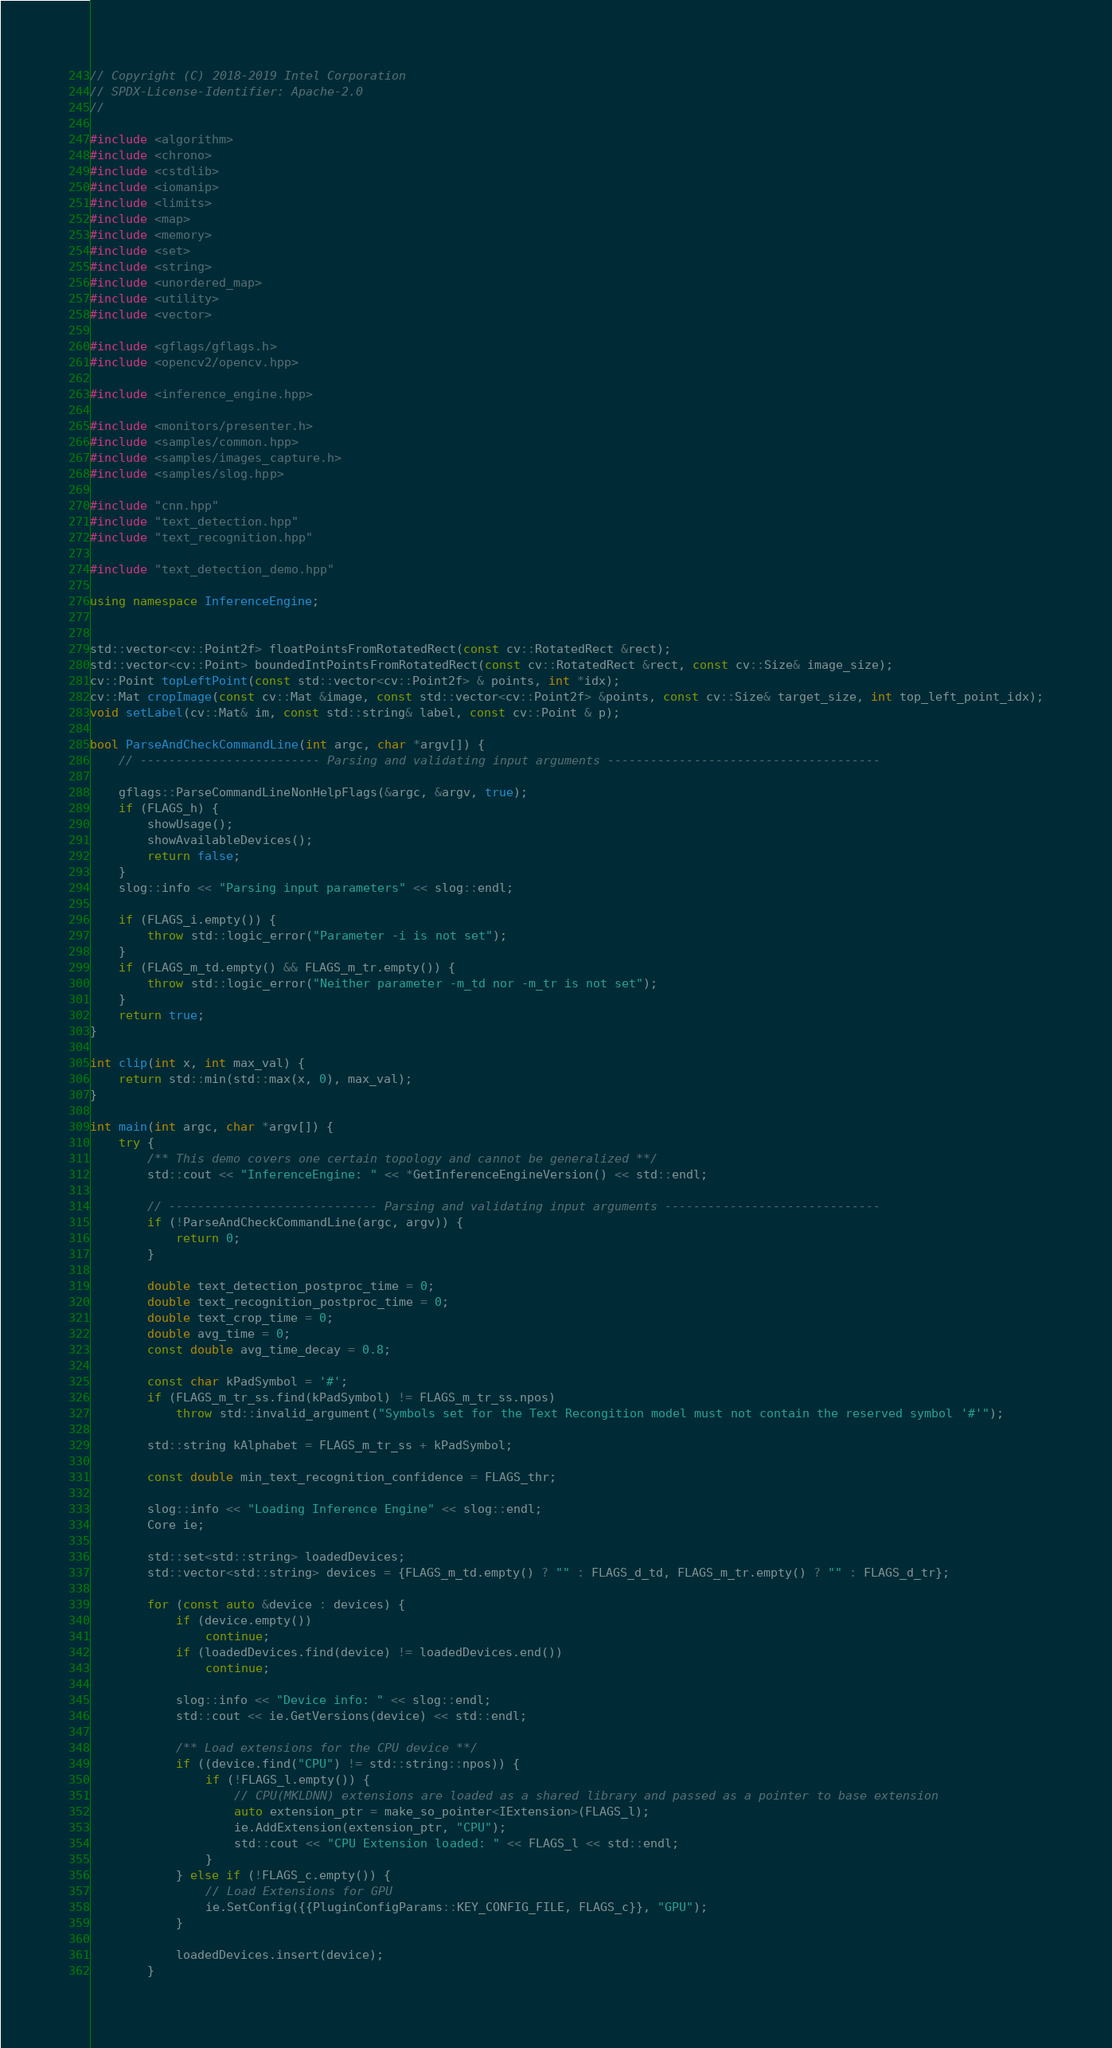Convert code to text. <code><loc_0><loc_0><loc_500><loc_500><_C++_>// Copyright (C) 2018-2019 Intel Corporation
// SPDX-License-Identifier: Apache-2.0
//

#include <algorithm>
#include <chrono>
#include <cstdlib>
#include <iomanip>
#include <limits>
#include <map>
#include <memory>
#include <set>
#include <string>
#include <unordered_map>
#include <utility>
#include <vector>

#include <gflags/gflags.h>
#include <opencv2/opencv.hpp>

#include <inference_engine.hpp>

#include <monitors/presenter.h>
#include <samples/common.hpp>
#include <samples/images_capture.h>
#include <samples/slog.hpp>

#include "cnn.hpp"
#include "text_detection.hpp"
#include "text_recognition.hpp"

#include "text_detection_demo.hpp"

using namespace InferenceEngine;


std::vector<cv::Point2f> floatPointsFromRotatedRect(const cv::RotatedRect &rect);
std::vector<cv::Point> boundedIntPointsFromRotatedRect(const cv::RotatedRect &rect, const cv::Size& image_size);
cv::Point topLeftPoint(const std::vector<cv::Point2f> & points, int *idx);
cv::Mat cropImage(const cv::Mat &image, const std::vector<cv::Point2f> &points, const cv::Size& target_size, int top_left_point_idx);
void setLabel(cv::Mat& im, const std::string& label, const cv::Point & p);

bool ParseAndCheckCommandLine(int argc, char *argv[]) {
    // ------------------------- Parsing and validating input arguments --------------------------------------

    gflags::ParseCommandLineNonHelpFlags(&argc, &argv, true);
    if (FLAGS_h) {
        showUsage();
        showAvailableDevices();
        return false;
    }
    slog::info << "Parsing input parameters" << slog::endl;

    if (FLAGS_i.empty()) {
        throw std::logic_error("Parameter -i is not set");
    }
    if (FLAGS_m_td.empty() && FLAGS_m_tr.empty()) {
        throw std::logic_error("Neither parameter -m_td nor -m_tr is not set");
    }
    return true;
}

int clip(int x, int max_val) {
    return std::min(std::max(x, 0), max_val);
}

int main(int argc, char *argv[]) {
    try {
        /** This demo covers one certain topology and cannot be generalized **/
        std::cout << "InferenceEngine: " << *GetInferenceEngineVersion() << std::endl;

        // ----------------------------- Parsing and validating input arguments ------------------------------
        if (!ParseAndCheckCommandLine(argc, argv)) {
            return 0;
        }

        double text_detection_postproc_time = 0;
        double text_recognition_postproc_time = 0;
        double text_crop_time = 0;
        double avg_time = 0;
        const double avg_time_decay = 0.8;

        const char kPadSymbol = '#';
        if (FLAGS_m_tr_ss.find(kPadSymbol) != FLAGS_m_tr_ss.npos)
            throw std::invalid_argument("Symbols set for the Text Recongition model must not contain the reserved symbol '#'");

        std::string kAlphabet = FLAGS_m_tr_ss + kPadSymbol;

        const double min_text_recognition_confidence = FLAGS_thr;

        slog::info << "Loading Inference Engine" << slog::endl;
        Core ie;

        std::set<std::string> loadedDevices;
        std::vector<std::string> devices = {FLAGS_m_td.empty() ? "" : FLAGS_d_td, FLAGS_m_tr.empty() ? "" : FLAGS_d_tr};

        for (const auto &device : devices) {
            if (device.empty())
                continue;
            if (loadedDevices.find(device) != loadedDevices.end())
                continue;

            slog::info << "Device info: " << slog::endl;
            std::cout << ie.GetVersions(device) << std::endl;

            /** Load extensions for the CPU device **/
            if ((device.find("CPU") != std::string::npos)) {
                if (!FLAGS_l.empty()) {
                    // CPU(MKLDNN) extensions are loaded as a shared library and passed as a pointer to base extension
                    auto extension_ptr = make_so_pointer<IExtension>(FLAGS_l);
                    ie.AddExtension(extension_ptr, "CPU");
                    std::cout << "CPU Extension loaded: " << FLAGS_l << std::endl;
                }
            } else if (!FLAGS_c.empty()) {
                // Load Extensions for GPU
                ie.SetConfig({{PluginConfigParams::KEY_CONFIG_FILE, FLAGS_c}}, "GPU");
            }

            loadedDevices.insert(device);
        }
</code> 